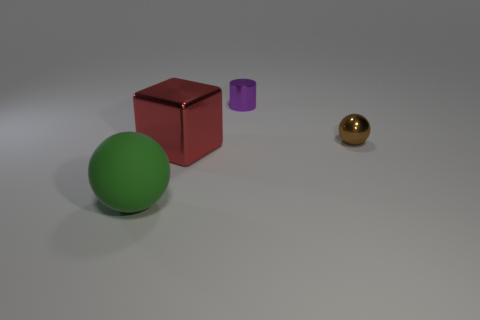Does the ball that is right of the cylinder have the same size as the small cylinder?
Your answer should be compact. Yes. There is a large thing that is behind the green matte thing; is its shape the same as the tiny brown thing?
Provide a succinct answer. No. What number of objects are balls or things right of the purple cylinder?
Your answer should be compact. 2. Are there fewer big yellow metallic things than red things?
Ensure brevity in your answer.  Yes. Is the number of cyan metal spheres greater than the number of tiny things?
Give a very brief answer. No. How many other things are the same material as the red cube?
Your response must be concise. 2. What number of green rubber spheres are to the left of the sphere that is behind the green sphere on the left side of the small purple shiny thing?
Provide a succinct answer. 1. What number of matte objects are cylinders or big red cubes?
Keep it short and to the point. 0. There is a ball behind the big object that is in front of the large red cube; how big is it?
Keep it short and to the point. Small. There is a tiny thing in front of the purple shiny cylinder; is it the same color as the large object behind the large ball?
Provide a succinct answer. No. 